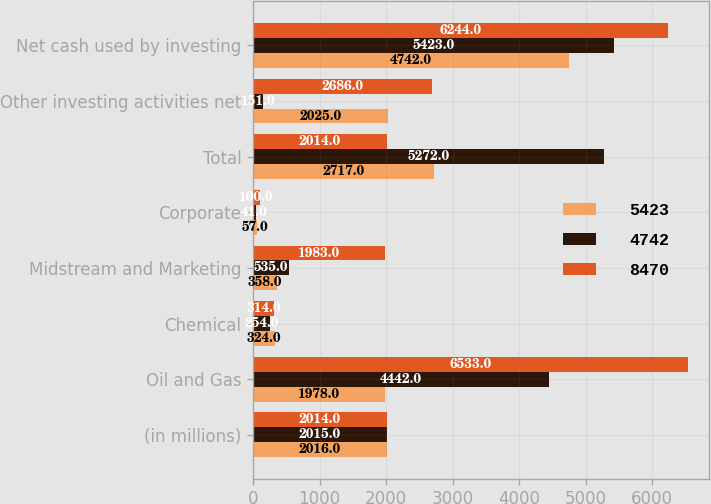Convert chart to OTSL. <chart><loc_0><loc_0><loc_500><loc_500><stacked_bar_chart><ecel><fcel>(in millions)<fcel>Oil and Gas<fcel>Chemical<fcel>Midstream and Marketing<fcel>Corporate<fcel>Total<fcel>Other investing activities net<fcel>Net cash used by investing<nl><fcel>5423<fcel>2016<fcel>1978<fcel>324<fcel>358<fcel>57<fcel>2717<fcel>2025<fcel>4742<nl><fcel>4742<fcel>2015<fcel>4442<fcel>254<fcel>535<fcel>41<fcel>5272<fcel>151<fcel>5423<nl><fcel>8470<fcel>2014<fcel>6533<fcel>314<fcel>1983<fcel>100<fcel>2014<fcel>2686<fcel>6244<nl></chart> 